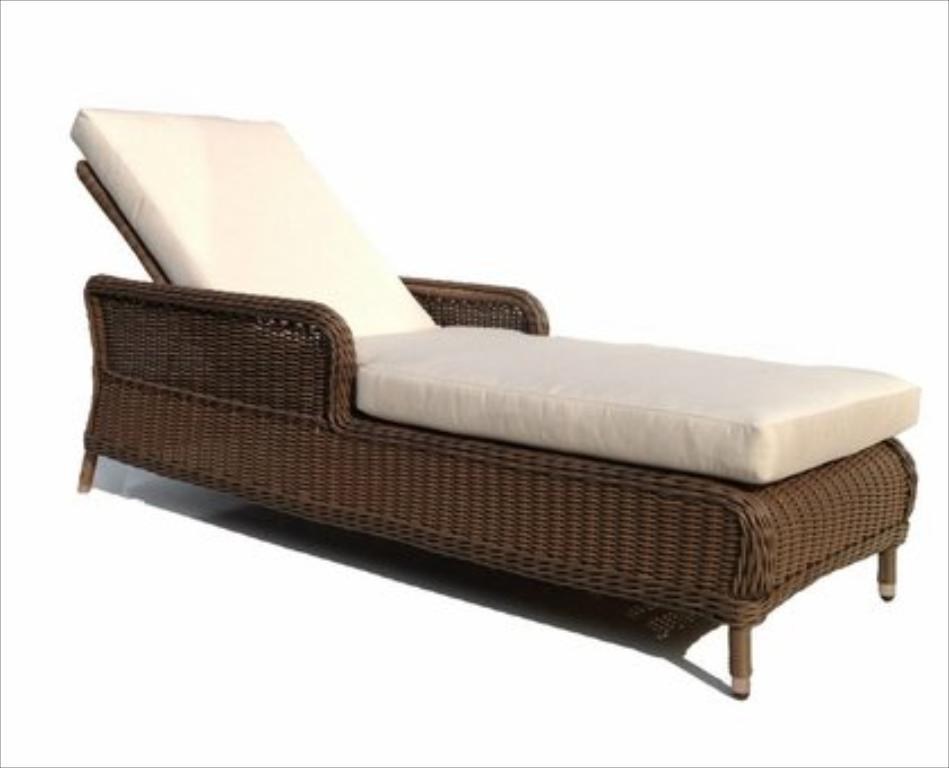How would you summarize this image in a sentence or two? In this image there is a sofa cum bed. A white cushion is placed on the wooden chair. 